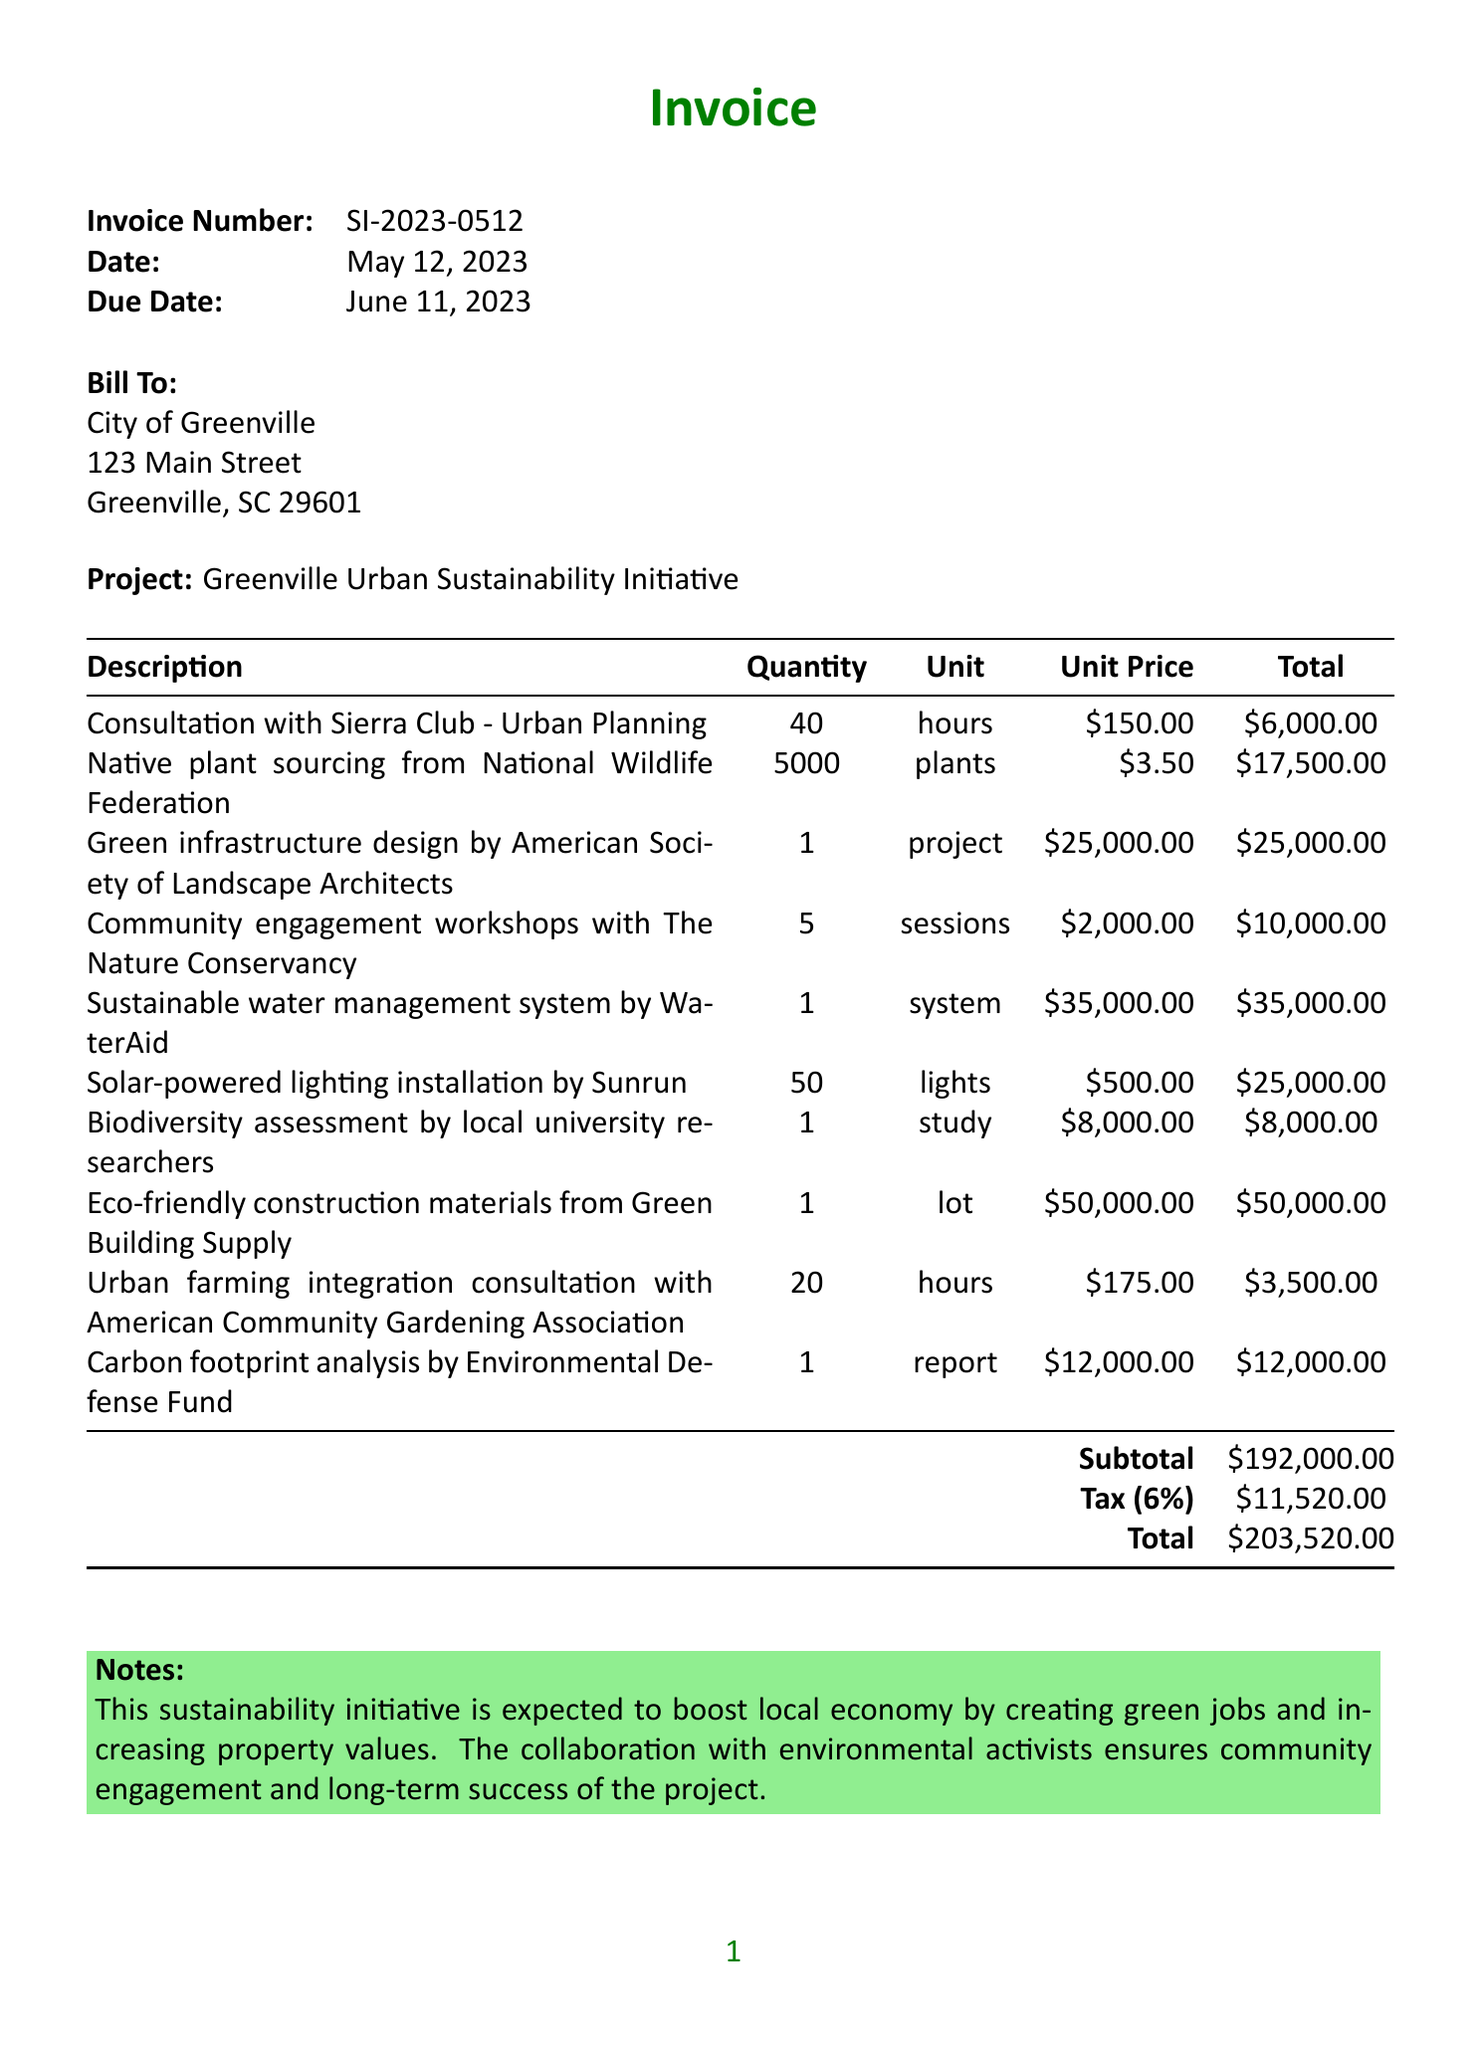what is the invoice number? The invoice number is specified in the document as SI-2023-0512.
Answer: SI-2023-0512 what is the due date of the invoice? The due date is indicated in the document as June 11, 2023.
Answer: June 11, 2023 how much is the total amount due? The total amount due is listed in the document as $203,520.00.
Answer: $203,520.00 what is the subtotal before tax? The subtotal before tax is shown as $192,000.00 in the document.
Answer: $192,000.00 who provided the consultation for urban planning? The consultation for urban planning was conducted by Sierra Club, as mentioned in the document.
Answer: Sierra Club how many native plants were sourced? The document states that 5,000 native plants were sourced.
Answer: 5000 what is the purpose of the community engagement workshops? The workshops aim to ensure community engagement, as noted in the document's notes section.
Answer: community engagement how many sessions of community engagement workshops were held? The document specifies that 5 sessions of community engagement workshops were conducted.
Answer: 5 what does the notes section say about the project? The notes state that the project is expected to boost the local economy by creating green jobs and increasing property values.
Answer: boost local economy what tax rate is applied to the invoice? The tax rate applied to the invoice is stated as 6%.
Answer: 6% 